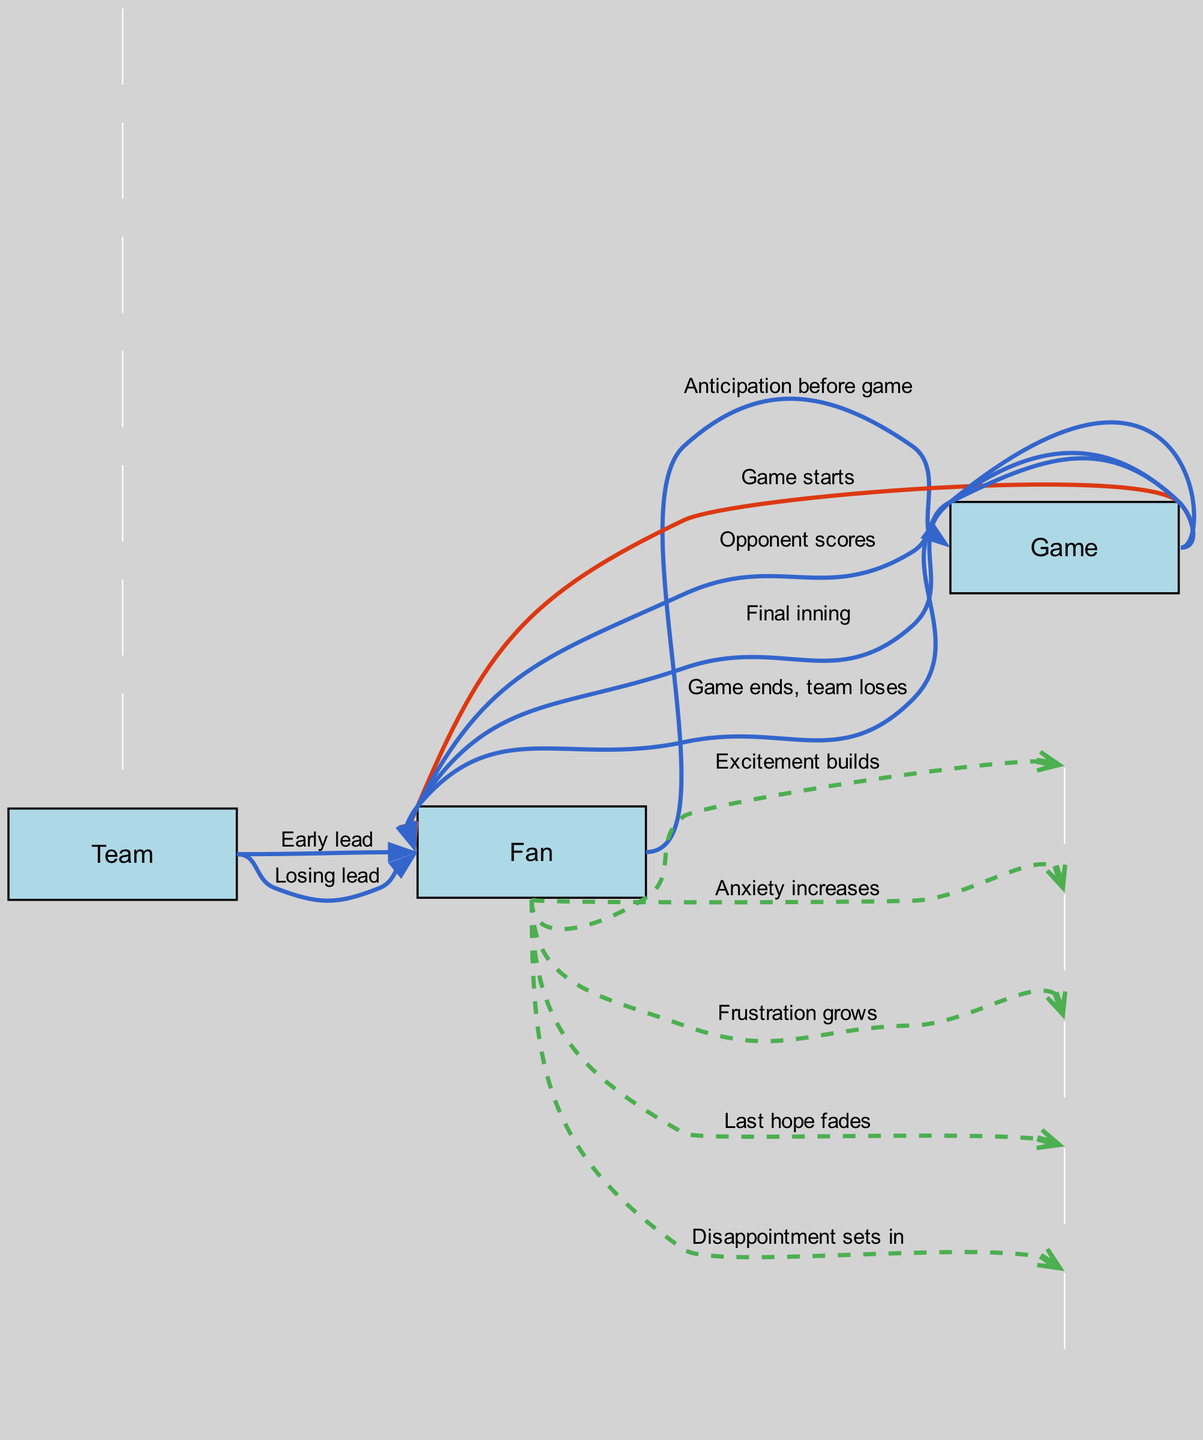What is the first message sent in the sequence? The first message in the sequence is "Anticipation before game," which is sent from the Fan to the Game.
Answer: Anticipation before game How many main actors are involved in the diagram? The diagram has three main actors: Fan, Team, and Game.
Answer: 3 What is the last message received by the Fan? The last message received by the Fan is "Game ends, team loses," which comes from the Game.
Answer: Game ends, team loses What message indicates the Fan's growing concern during the game? The message "Anxiety increases" indicates the Fan's growing concern and is sent from the Fan to themselves.
Answer: Anxiety increases Which message reflects the Fan's last moment of hope? The message "Last hope fades" reflects the Fan's last moment of hope, sent from the Fan to themselves.
Answer: Last hope fades What results in the Fan feeling disappointment? The Fan feels disappointment after receiving the last message, "Game ends, team loses," from the Game.
Answer: Disappointment sets in How many messages in total are sent in the sequence? In total, there are twelve messages sent throughout the sequence, covering various emotional states and events.
Answer: 12 Which actor sends a message about losing a lead? The Team sends the message "Losing lead" to the Fan, indicating the shift in the game's outcome.
Answer: Team What emotional state does the Fan experience right after the opponent scores? After the opponent scores, the Fan experiences "Anxiety increases," which reflects their heightened concern.
Answer: Anxiety increases 